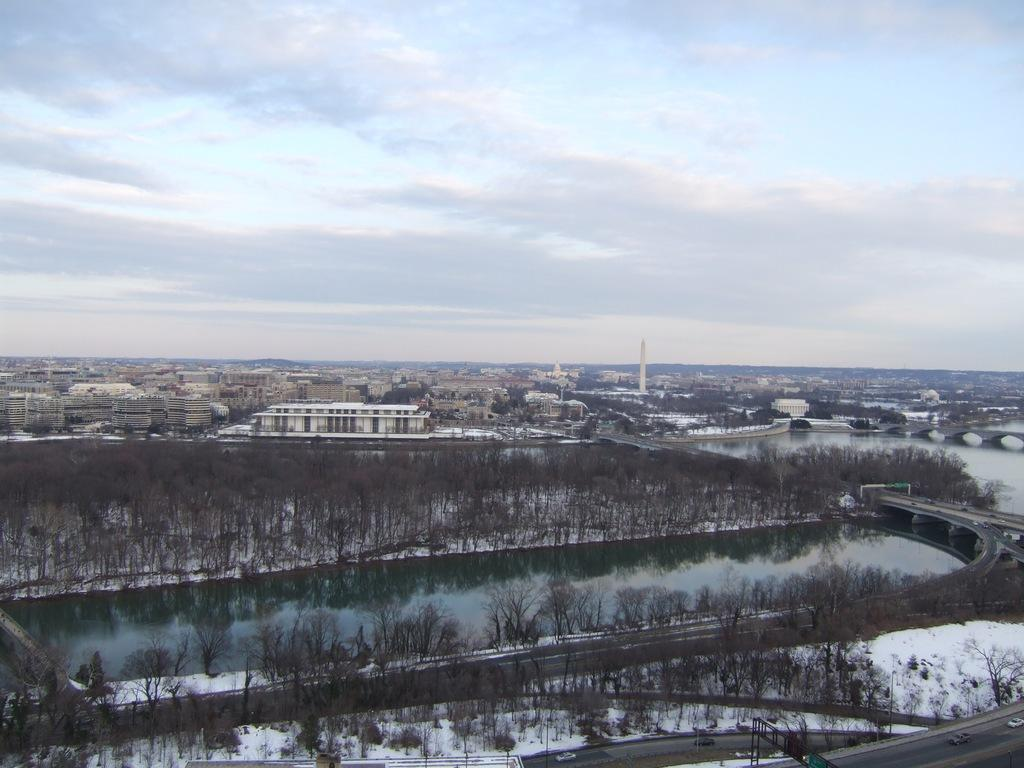What is the main subject in the middle of the image? There is a water dam in the middle of the image. What is the surrounding environment of the water dam? The water dam is surrounded by snow. What can be seen in the background of the image? There are many buildings in the background of the image. What type of texture can be seen on the wrench in the image? There is no wrench present in the image. How does the addition of a new building affect the water flow in the image? There is no information about the addition of a new building or its impact on the water flow in the image. 